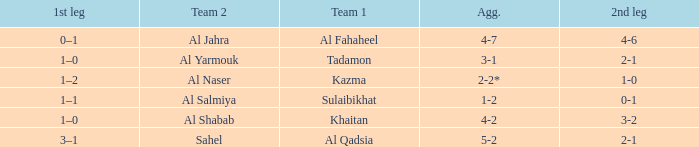What is the 1st leg of the Al Fahaheel Team 1? 0–1. Could you help me parse every detail presented in this table? {'header': ['1st leg', 'Team 2', 'Team 1', 'Agg.', '2nd leg'], 'rows': [['0–1', 'Al Jahra', 'Al Fahaheel', '4-7', '4-6'], ['1–0', 'Al Yarmouk', 'Tadamon', '3-1', '2-1'], ['1–2', 'Al Naser', 'Kazma', '2-2*', '1-0'], ['1–1', 'Al Salmiya', 'Sulaibikhat', '1-2', '0-1'], ['1–0', 'Al Shabab', 'Khaitan', '4-2', '3-2'], ['3–1', 'Sahel', 'Al Qadsia', '5-2', '2-1']]} 